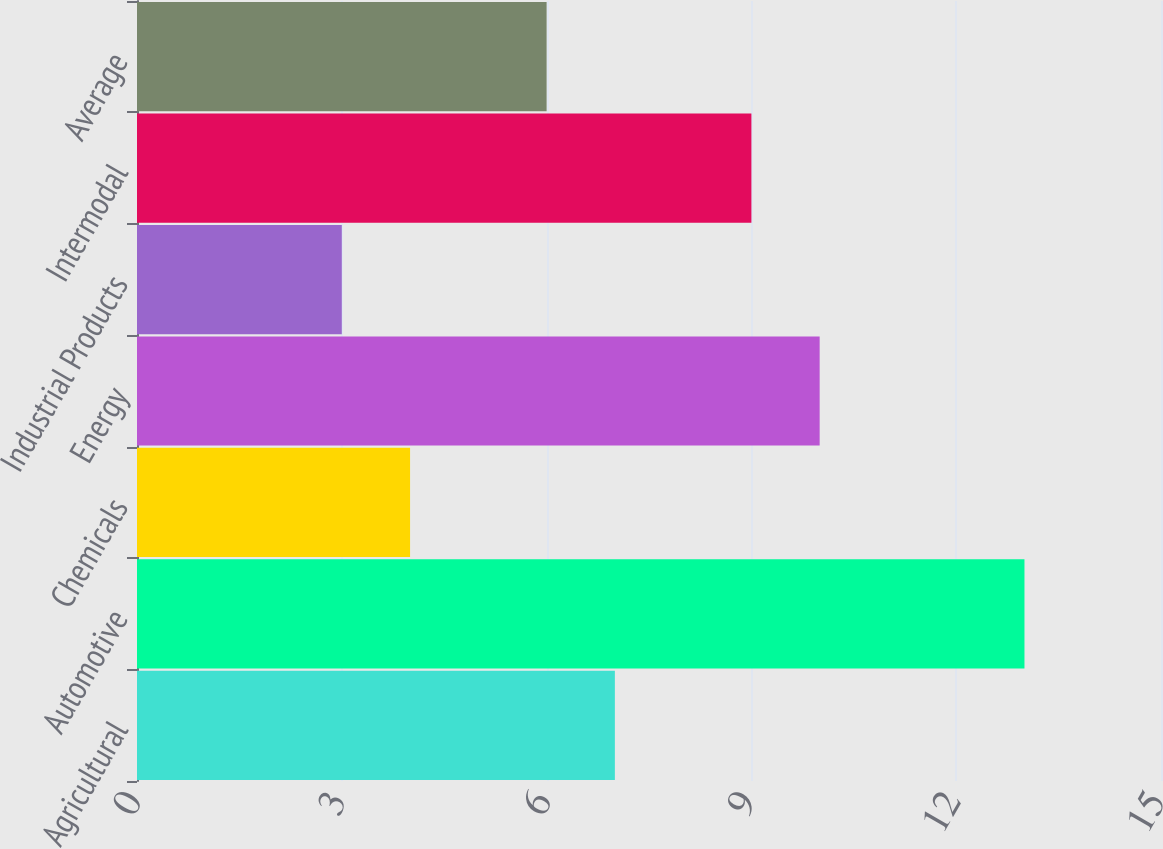Convert chart to OTSL. <chart><loc_0><loc_0><loc_500><loc_500><bar_chart><fcel>Agricultural<fcel>Automotive<fcel>Chemicals<fcel>Energy<fcel>Industrial Products<fcel>Intermodal<fcel>Average<nl><fcel>7<fcel>13<fcel>4<fcel>10<fcel>3<fcel>9<fcel>6<nl></chart> 